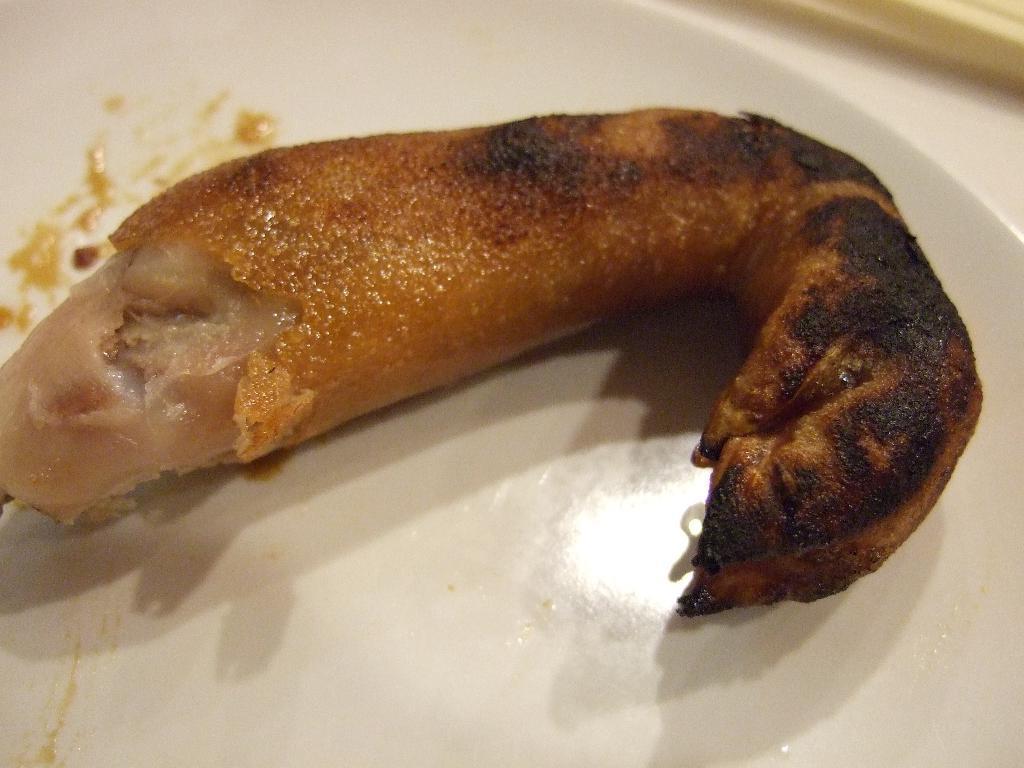Please provide a concise description of this image. Here there is a food item in the white color plate. 